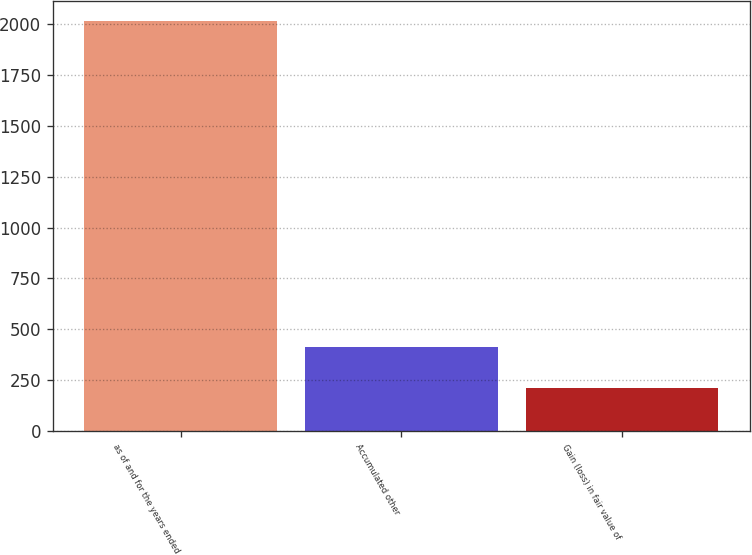<chart> <loc_0><loc_0><loc_500><loc_500><bar_chart><fcel>as of and for the years ended<fcel>Accumulated other<fcel>Gain (loss) in fair value of<nl><fcel>2014<fcel>410.8<fcel>210.4<nl></chart> 